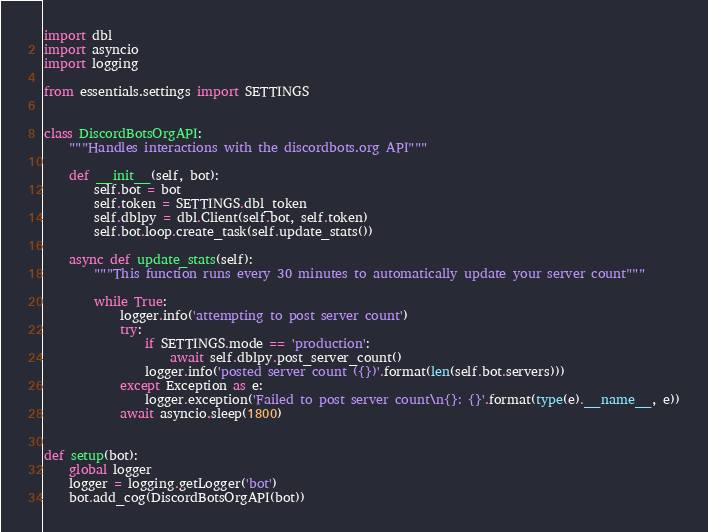<code> <loc_0><loc_0><loc_500><loc_500><_Python_>import dbl
import asyncio
import logging

from essentials.settings import SETTINGS


class DiscordBotsOrgAPI:
    """Handles interactions with the discordbots.org API"""

    def __init__(self, bot):
        self.bot = bot
        self.token = SETTINGS.dbl_token
        self.dblpy = dbl.Client(self.bot, self.token)
        self.bot.loop.create_task(self.update_stats())

    async def update_stats(self):
        """This function runs every 30 minutes to automatically update your server count"""

        while True:
            logger.info('attempting to post server count')
            try:
                if SETTINGS.mode == 'production':
                    await self.dblpy.post_server_count()
                logger.info('posted server count ({})'.format(len(self.bot.servers)))
            except Exception as e:
                logger.exception('Failed to post server count\n{}: {}'.format(type(e).__name__, e))
            await asyncio.sleep(1800)


def setup(bot):
    global logger
    logger = logging.getLogger('bot')
    bot.add_cog(DiscordBotsOrgAPI(bot))</code> 